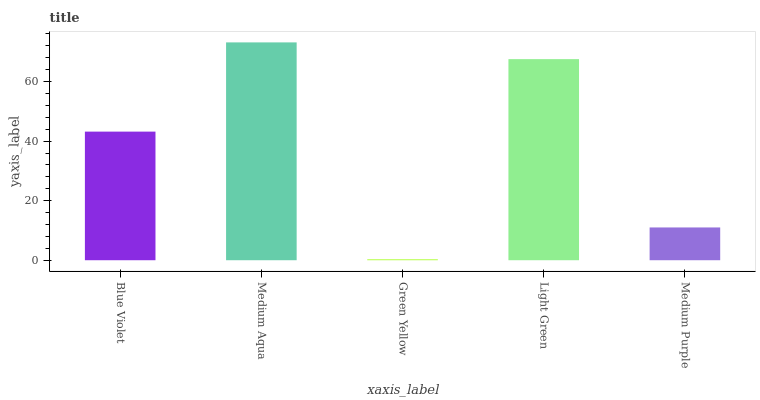Is Medium Aqua the minimum?
Answer yes or no. No. Is Green Yellow the maximum?
Answer yes or no. No. Is Medium Aqua greater than Green Yellow?
Answer yes or no. Yes. Is Green Yellow less than Medium Aqua?
Answer yes or no. Yes. Is Green Yellow greater than Medium Aqua?
Answer yes or no. No. Is Medium Aqua less than Green Yellow?
Answer yes or no. No. Is Blue Violet the high median?
Answer yes or no. Yes. Is Blue Violet the low median?
Answer yes or no. Yes. Is Light Green the high median?
Answer yes or no. No. Is Medium Purple the low median?
Answer yes or no. No. 